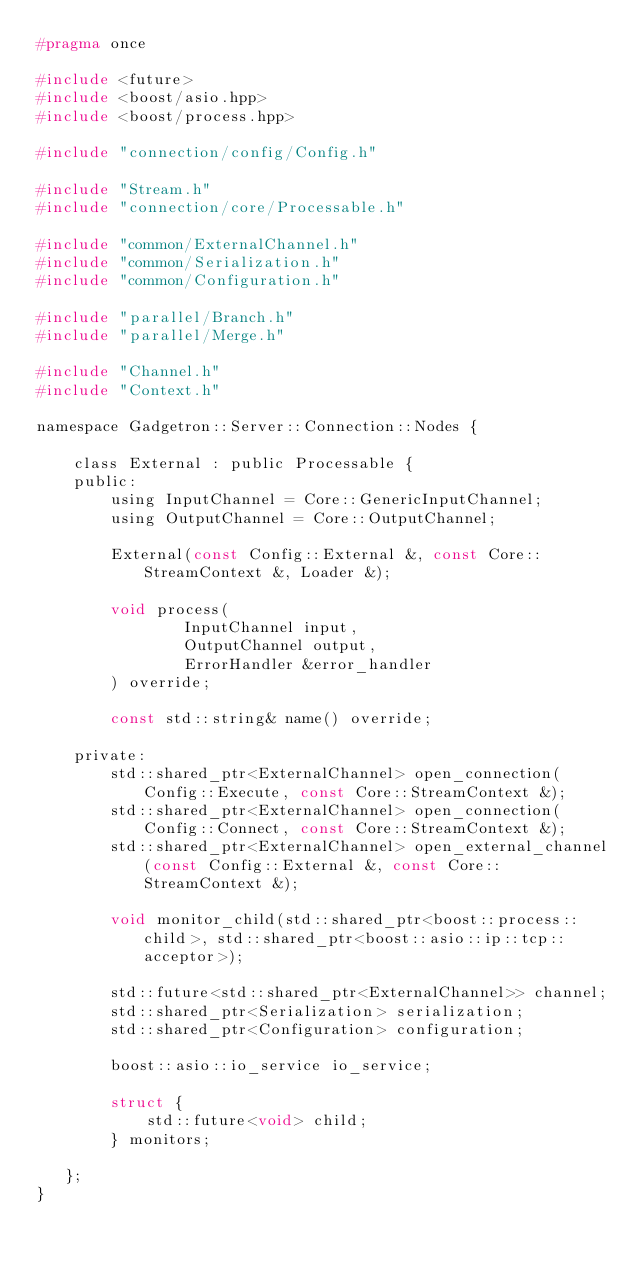Convert code to text. <code><loc_0><loc_0><loc_500><loc_500><_C_>#pragma once

#include <future>
#include <boost/asio.hpp>
#include <boost/process.hpp>

#include "connection/config/Config.h"

#include "Stream.h"
#include "connection/core/Processable.h"

#include "common/ExternalChannel.h"
#include "common/Serialization.h"
#include "common/Configuration.h"

#include "parallel/Branch.h"
#include "parallel/Merge.h"

#include "Channel.h"
#include "Context.h"

namespace Gadgetron::Server::Connection::Nodes {

    class External : public Processable {
    public:
        using InputChannel = Core::GenericInputChannel;
        using OutputChannel = Core::OutputChannel;

        External(const Config::External &, const Core::StreamContext &, Loader &);

        void process(
                InputChannel input,
                OutputChannel output,
                ErrorHandler &error_handler
        ) override;

        const std::string& name() override;

    private:
        std::shared_ptr<ExternalChannel> open_connection(Config::Execute, const Core::StreamContext &);
        std::shared_ptr<ExternalChannel> open_connection(Config::Connect, const Core::StreamContext &);
        std::shared_ptr<ExternalChannel> open_external_channel(const Config::External &, const Core::StreamContext &);

        void monitor_child(std::shared_ptr<boost::process::child>, std::shared_ptr<boost::asio::ip::tcp::acceptor>);

        std::future<std::shared_ptr<ExternalChannel>> channel;
        std::shared_ptr<Serialization> serialization;
        std::shared_ptr<Configuration> configuration;

        boost::asio::io_service io_service;

        struct {
            std::future<void> child;
        } monitors;

   };
}</code> 